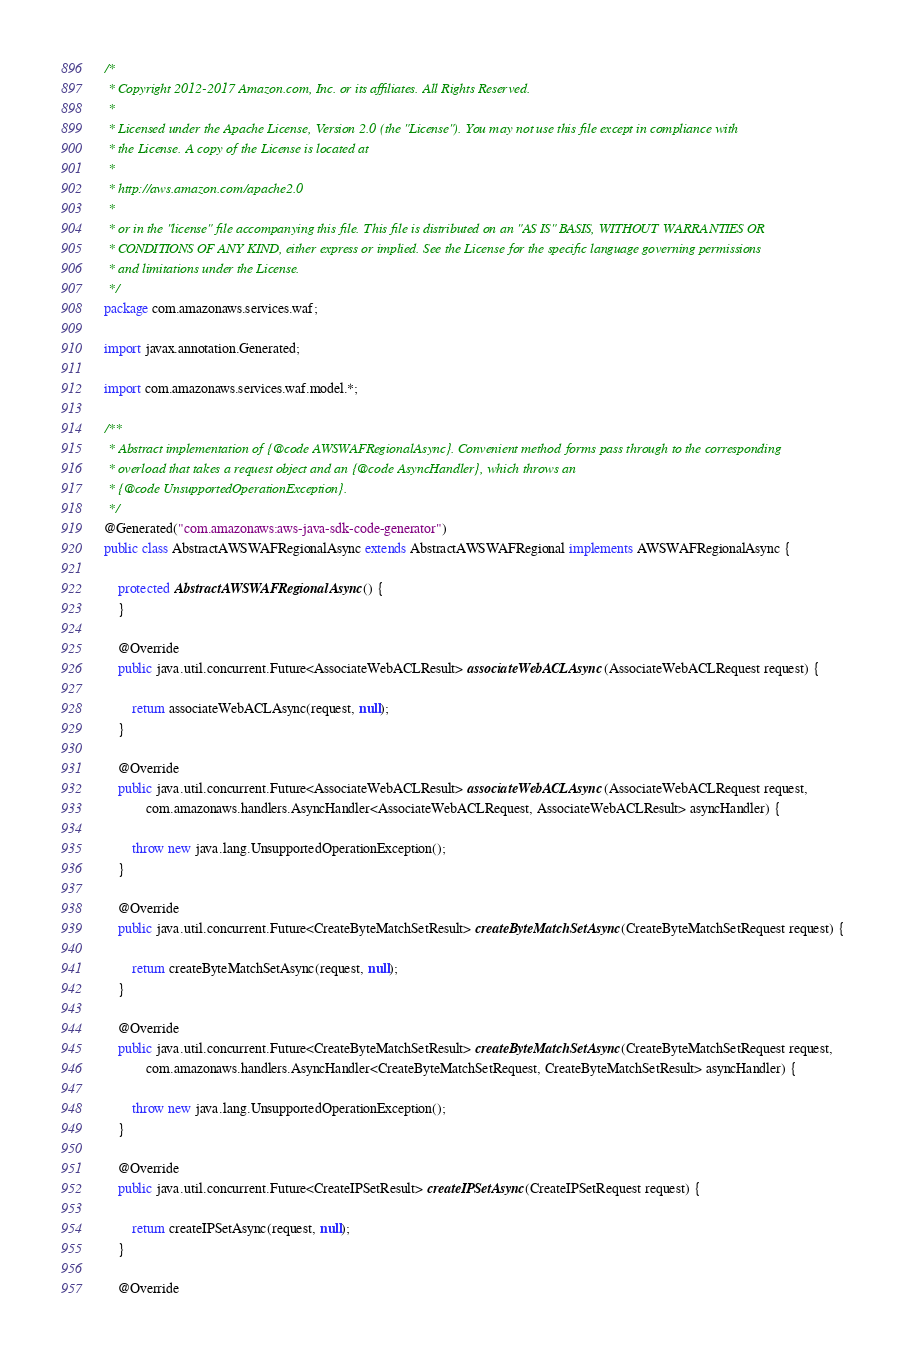<code> <loc_0><loc_0><loc_500><loc_500><_Java_>/*
 * Copyright 2012-2017 Amazon.com, Inc. or its affiliates. All Rights Reserved.
 * 
 * Licensed under the Apache License, Version 2.0 (the "License"). You may not use this file except in compliance with
 * the License. A copy of the License is located at
 * 
 * http://aws.amazon.com/apache2.0
 * 
 * or in the "license" file accompanying this file. This file is distributed on an "AS IS" BASIS, WITHOUT WARRANTIES OR
 * CONDITIONS OF ANY KIND, either express or implied. See the License for the specific language governing permissions
 * and limitations under the License.
 */
package com.amazonaws.services.waf;

import javax.annotation.Generated;

import com.amazonaws.services.waf.model.*;

/**
 * Abstract implementation of {@code AWSWAFRegionalAsync}. Convenient method forms pass through to the corresponding
 * overload that takes a request object and an {@code AsyncHandler}, which throws an
 * {@code UnsupportedOperationException}.
 */
@Generated("com.amazonaws:aws-java-sdk-code-generator")
public class AbstractAWSWAFRegionalAsync extends AbstractAWSWAFRegional implements AWSWAFRegionalAsync {

    protected AbstractAWSWAFRegionalAsync() {
    }

    @Override
    public java.util.concurrent.Future<AssociateWebACLResult> associateWebACLAsync(AssociateWebACLRequest request) {

        return associateWebACLAsync(request, null);
    }

    @Override
    public java.util.concurrent.Future<AssociateWebACLResult> associateWebACLAsync(AssociateWebACLRequest request,
            com.amazonaws.handlers.AsyncHandler<AssociateWebACLRequest, AssociateWebACLResult> asyncHandler) {

        throw new java.lang.UnsupportedOperationException();
    }

    @Override
    public java.util.concurrent.Future<CreateByteMatchSetResult> createByteMatchSetAsync(CreateByteMatchSetRequest request) {

        return createByteMatchSetAsync(request, null);
    }

    @Override
    public java.util.concurrent.Future<CreateByteMatchSetResult> createByteMatchSetAsync(CreateByteMatchSetRequest request,
            com.amazonaws.handlers.AsyncHandler<CreateByteMatchSetRequest, CreateByteMatchSetResult> asyncHandler) {

        throw new java.lang.UnsupportedOperationException();
    }

    @Override
    public java.util.concurrent.Future<CreateIPSetResult> createIPSetAsync(CreateIPSetRequest request) {

        return createIPSetAsync(request, null);
    }

    @Override</code> 